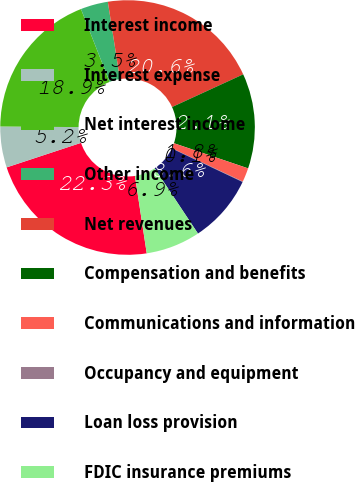<chart> <loc_0><loc_0><loc_500><loc_500><pie_chart><fcel>Interest income<fcel>Interest expense<fcel>Net interest income<fcel>Other income<fcel>Net revenues<fcel>Compensation and benefits<fcel>Communications and information<fcel>Occupancy and equipment<fcel>Loan loss provision<fcel>FDIC insurance premiums<nl><fcel>22.34%<fcel>5.2%<fcel>18.91%<fcel>3.49%<fcel>20.62%<fcel>12.06%<fcel>1.78%<fcel>0.06%<fcel>8.63%<fcel>6.92%<nl></chart> 